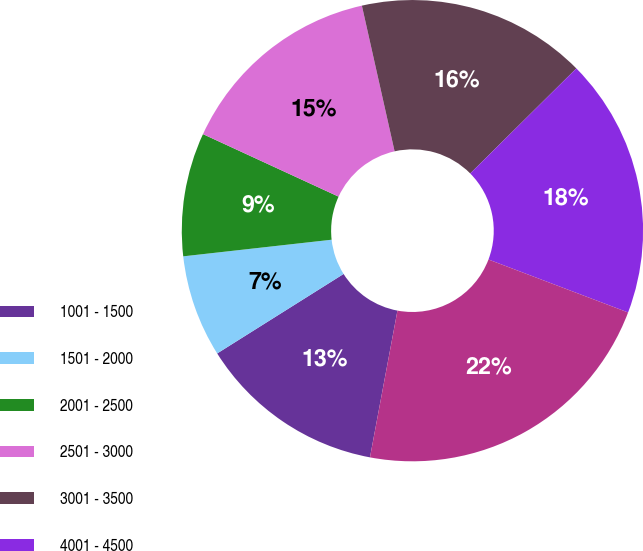Convert chart to OTSL. <chart><loc_0><loc_0><loc_500><loc_500><pie_chart><fcel>1001 - 1500<fcel>1501 - 2000<fcel>2001 - 2500<fcel>2501 - 3000<fcel>3001 - 3500<fcel>4001 - 4500<fcel>4501 - 5000<nl><fcel>13.12%<fcel>7.16%<fcel>8.65%<fcel>14.61%<fcel>16.1%<fcel>18.19%<fcel>22.18%<nl></chart> 